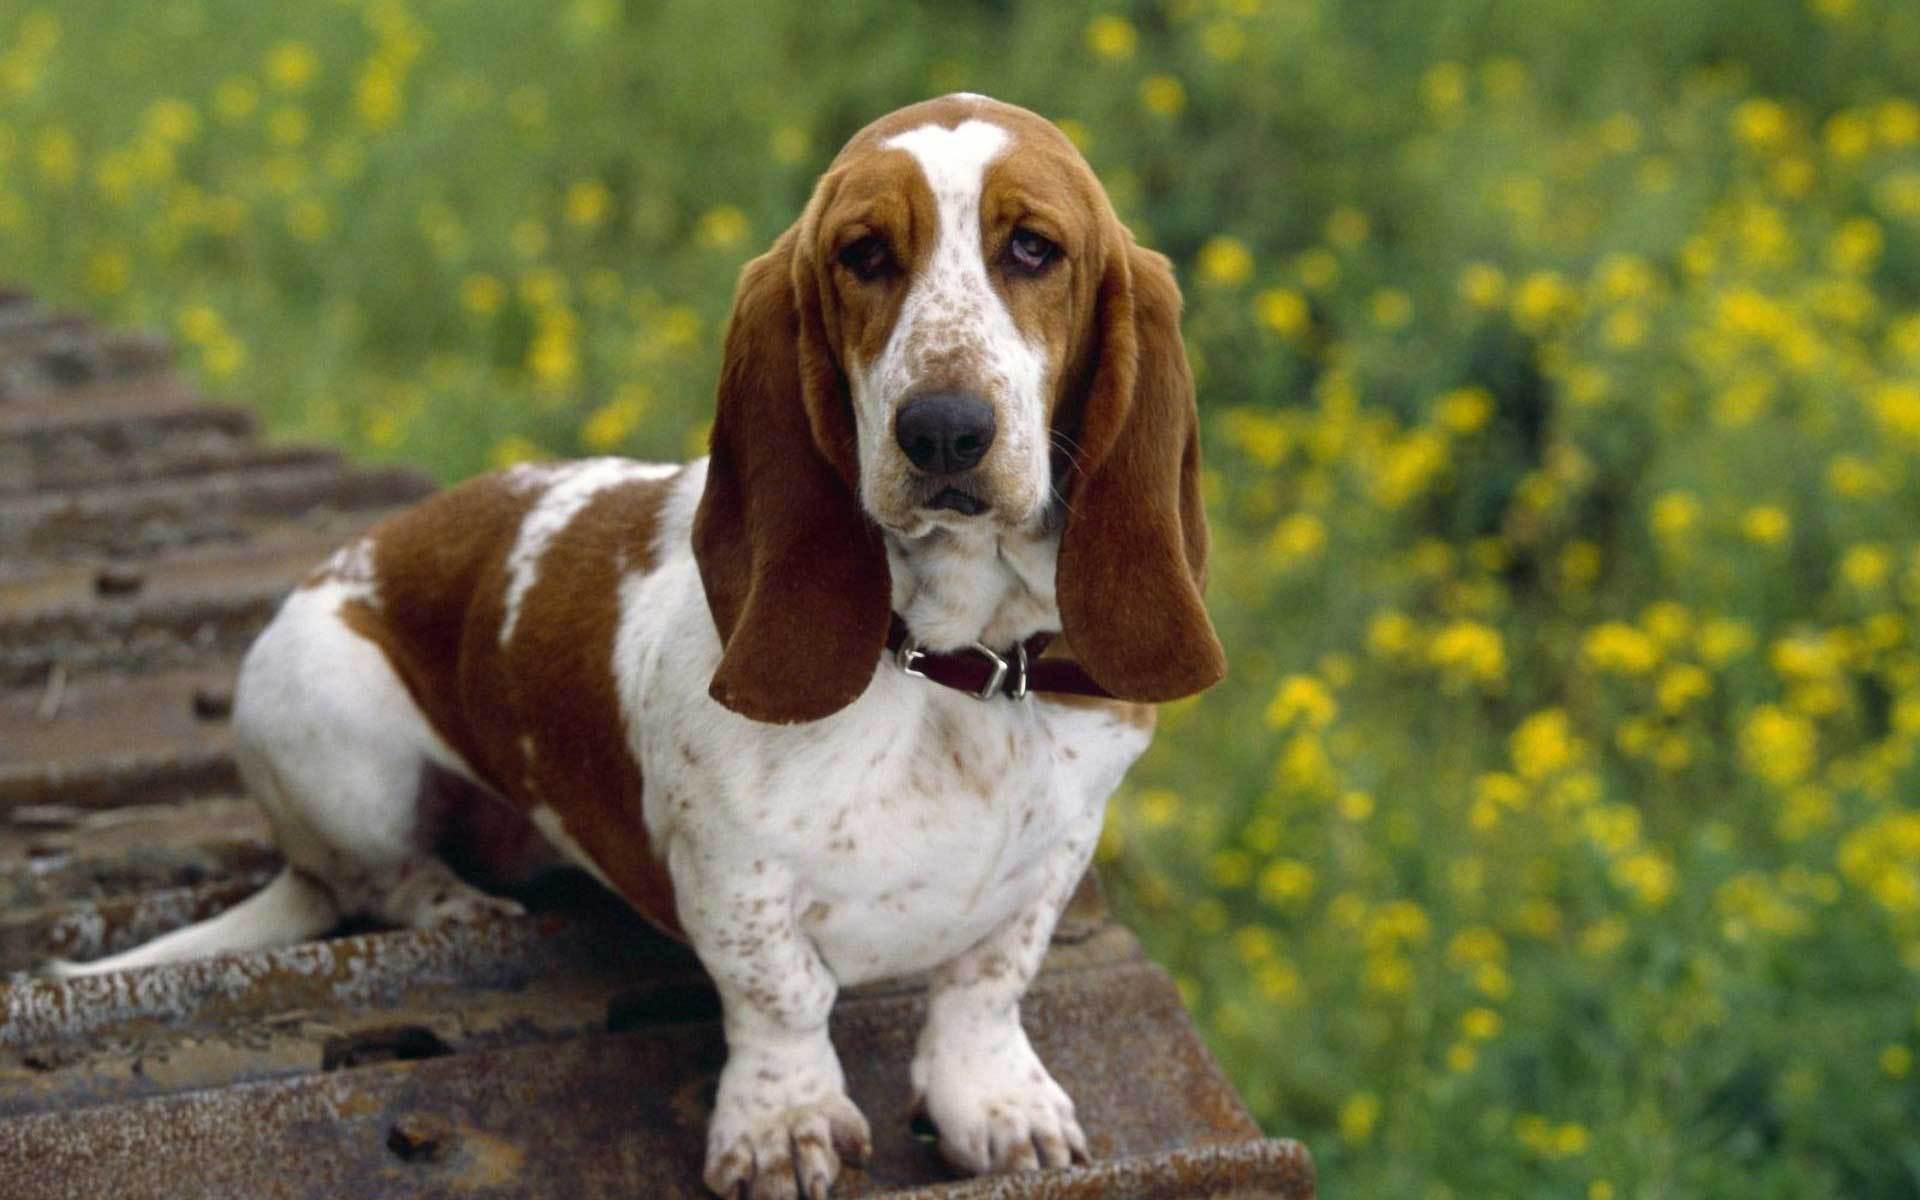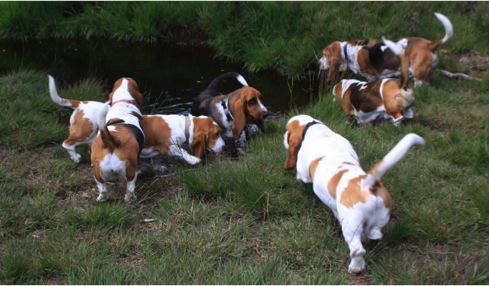The first image is the image on the left, the second image is the image on the right. Considering the images on both sides, is "One image shows just one beagle, with no leash attached." valid? Answer yes or no. Yes. The first image is the image on the left, the second image is the image on the right. Evaluate the accuracy of this statement regarding the images: "One of the images shows at least one dog on a leash.". Is it true? Answer yes or no. No. 